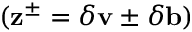<formula> <loc_0><loc_0><loc_500><loc_500>( z ^ { \pm } = \delta v \pm \delta b )</formula> 